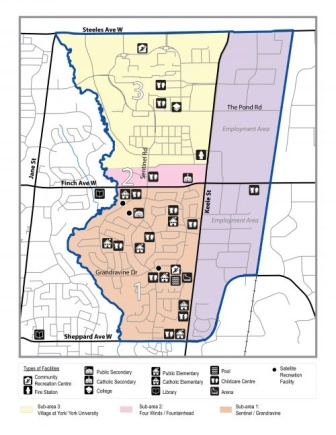Can you provide a detailed tour of the map's neighborhood? Absolutely! Let's start from the top of the map. The top section, which is primarily residential, hosts a mix of facilities including a Catholic elementary school and several parks. Moving southward into the middle section, this area is dominantly commercial, featuring a higher density of facilities such as community centers and public schools. Streets like 'The Pond Rd' and 'Finch Ave W' are crucial thoroughfares in this area. Finally, the bottom section, returning to a residential layout, includes additional educational facilities, such as public and Catholic schools, and more community spaces. Main roads, such as 'Steeles Ave W' and 'Sheppard Ave W', frame the neighborhood, facilitating ease of access. The color-coded sections distinctly show the different facilities, making the neighborhood easy to navigate and understand. What might a day in the life of a resident here look like? A resident in this neighborhood might start their day by taking their children to a nearby public or Catholic elementary school, easily identified on the map in yellow or pink respectively. Afterward, they may head to the commercial center in the middle section for work or shopping, taking main streets like 'Finch Ave W'. Afternoons could be spent at one of the green spaces, possibly a park or a community center. Evening activities might include attending events at community buildings or enjoying recreational facilities. The well-marked facilities ensure a blend of educational, commercial, and recreational opportunities for a balanced daily life. 